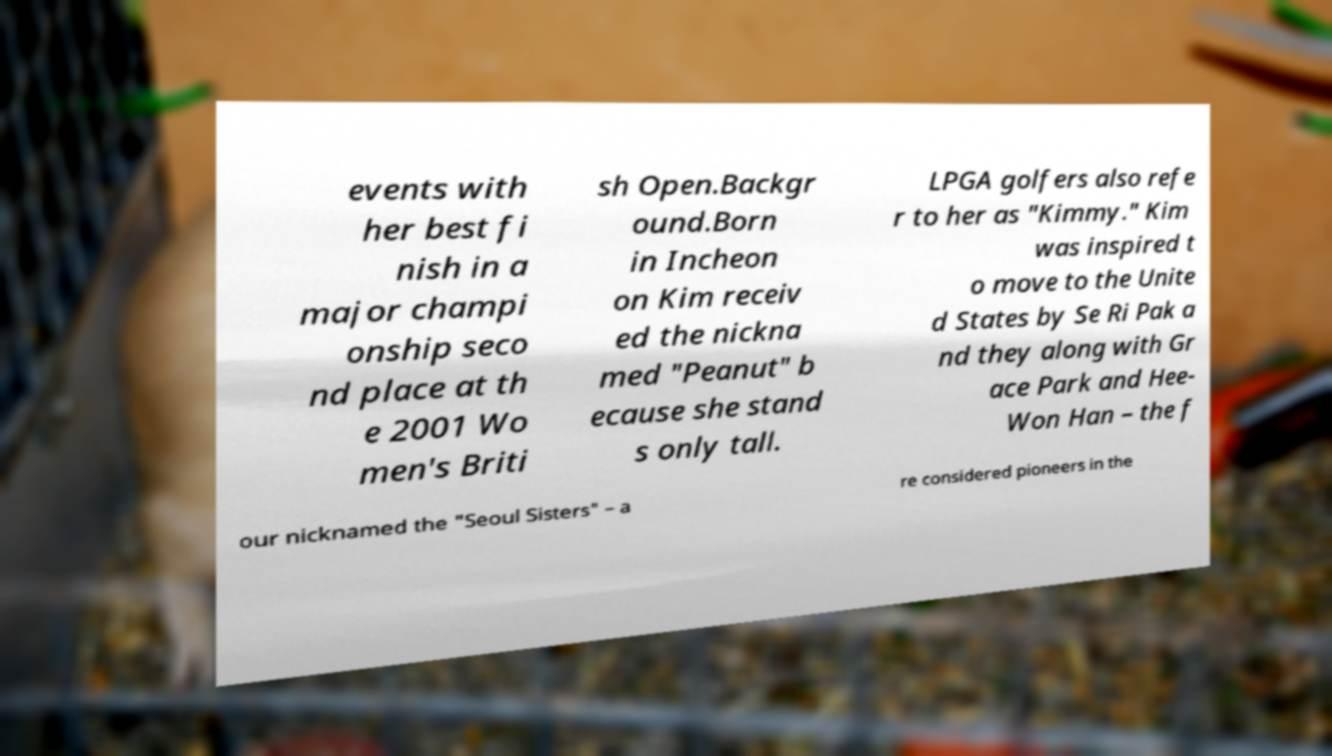Please read and relay the text visible in this image. What does it say? events with her best fi nish in a major champi onship seco nd place at th e 2001 Wo men's Briti sh Open.Backgr ound.Born in Incheon on Kim receiv ed the nickna med "Peanut" b ecause she stand s only tall. LPGA golfers also refe r to her as "Kimmy." Kim was inspired t o move to the Unite d States by Se Ri Pak a nd they along with Gr ace Park and Hee- Won Han – the f our nicknamed the "Seoul Sisters" – a re considered pioneers in the 